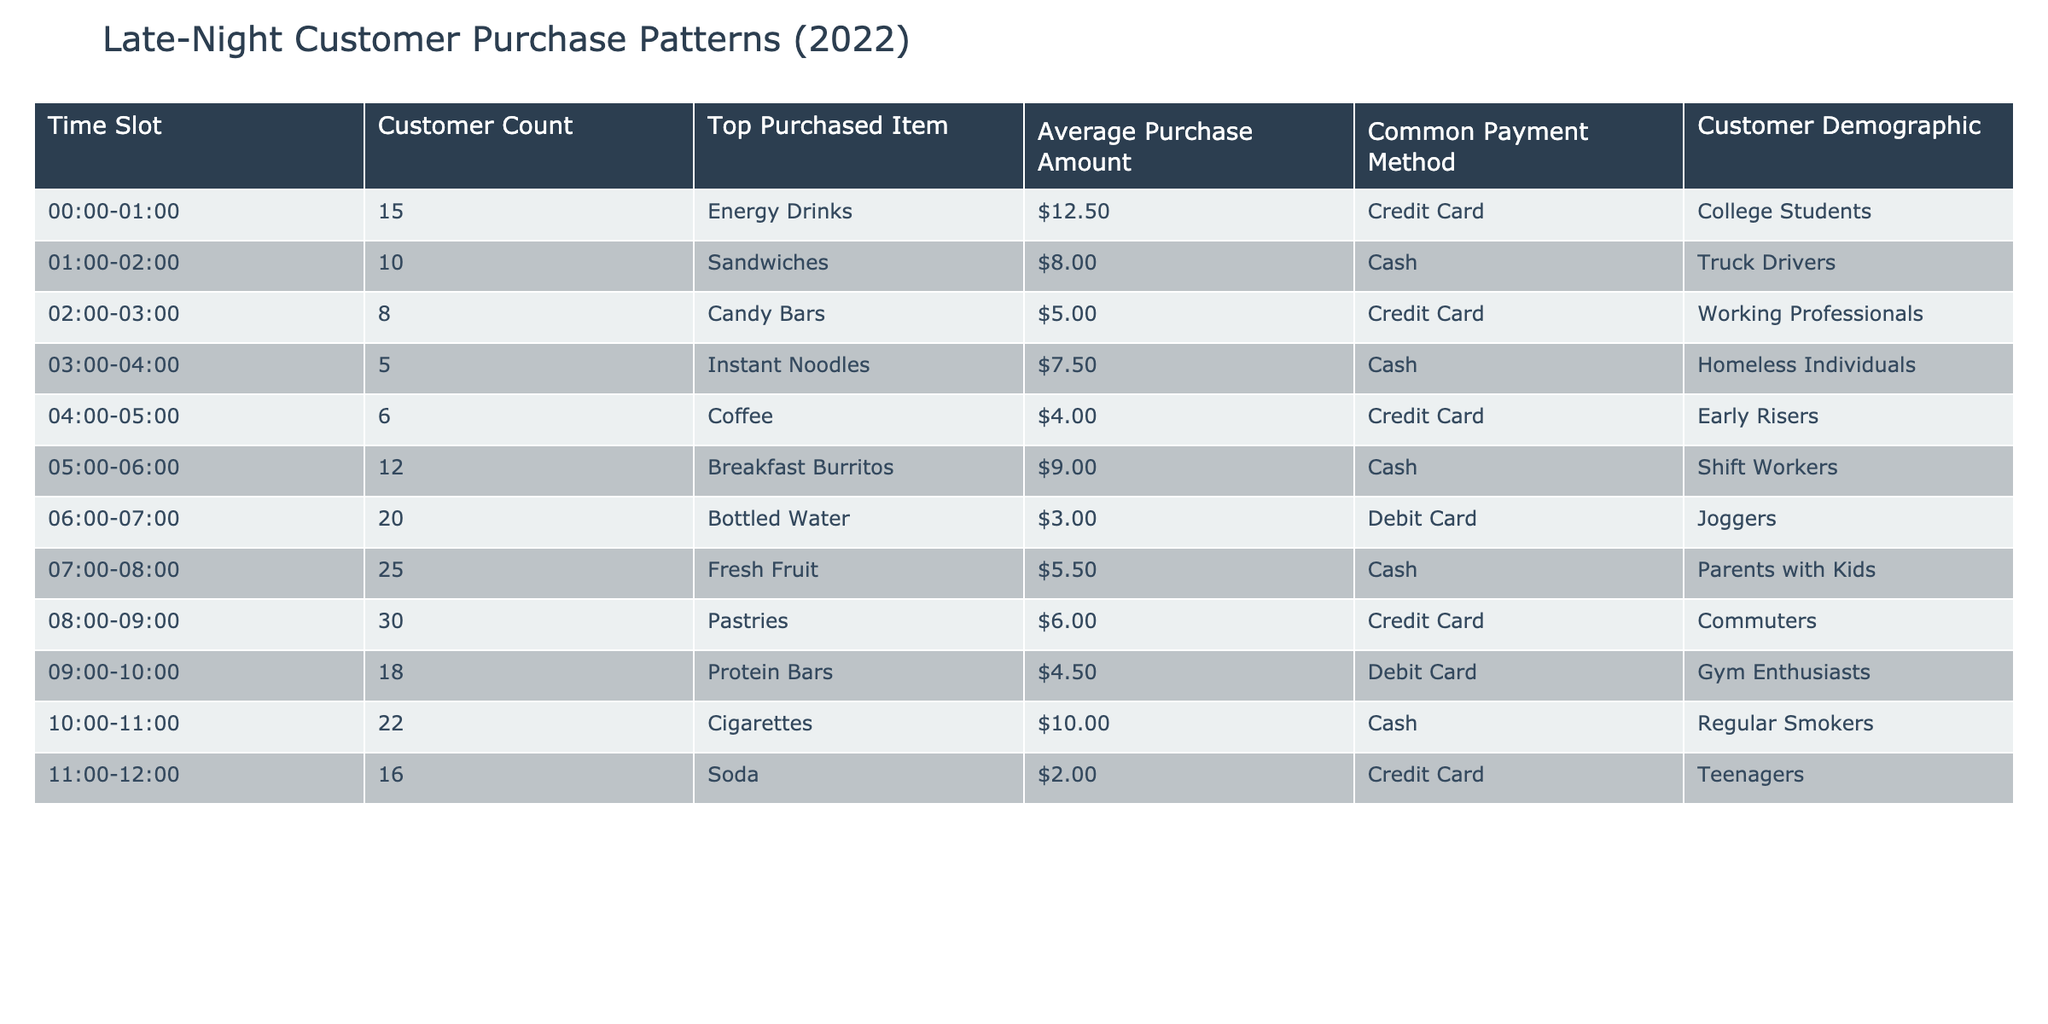What is the top purchased item between 4:00 and 5:00? The time slot for 4:00 to 5:00 shows that the top purchased item is Coffee.
Answer: Coffee How many customers purchased items from 6:00 to 7:00? The customer count in the time slot from 6:00 to 7:00 is 20.
Answer: 20 What is the average purchase amount for sandwiches? The average purchase amount for sandwiches, which are top purchases in the 1:00 to 2:00 time slot, is $8.00.
Answer: $8.00 Is the top purchased item for the 2:00 to 3:00 time slot an energy drink? The top purchased item during that time slot is Candy Bars, not energy drinks, so the statement is false.
Answer: No What is the difference in customer count between the time slots of 11:00-12:00 and 00:00-01:00? The customer count for 11:00 to 12:00 is 16 and for 00:00 to 01:00 is 15. The difference is 16 - 15 = 1.
Answer: 1 Which payment method is most commonly used for purchasing energy drinks? For energy drinks purchased in the 00:00 to 01:00 time slot, the common payment method is Credit Card.
Answer: Credit Card During which time slot do the least number of customers make purchases? The least number of customers corresponds to the time slot of 3:00 to 4:00 with only 5 customers.
Answer: 3:00 to 4:00 What is the total average purchase amount for the first three time slots? The average purchase amounts are $12.50 for energy drinks, $8.00 for sandwiches, and $5.00 for candy bars. Their total is 12.50 + 8.00 + 5.00 = 25.50; the average will then be 25.50 / 3 = 8.50.
Answer: $8.50 Which demographic purchased breakfast burritos? The demographic associated with purchasing breakfast burritos in the 5:00 to 6:00 time slot is Shift Workers.
Answer: Shift Workers 